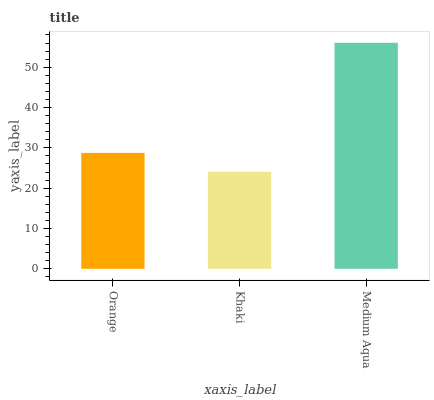Is Khaki the minimum?
Answer yes or no. Yes. Is Medium Aqua the maximum?
Answer yes or no. Yes. Is Medium Aqua the minimum?
Answer yes or no. No. Is Khaki the maximum?
Answer yes or no. No. Is Medium Aqua greater than Khaki?
Answer yes or no. Yes. Is Khaki less than Medium Aqua?
Answer yes or no. Yes. Is Khaki greater than Medium Aqua?
Answer yes or no. No. Is Medium Aqua less than Khaki?
Answer yes or no. No. Is Orange the high median?
Answer yes or no. Yes. Is Orange the low median?
Answer yes or no. Yes. Is Khaki the high median?
Answer yes or no. No. Is Khaki the low median?
Answer yes or no. No. 